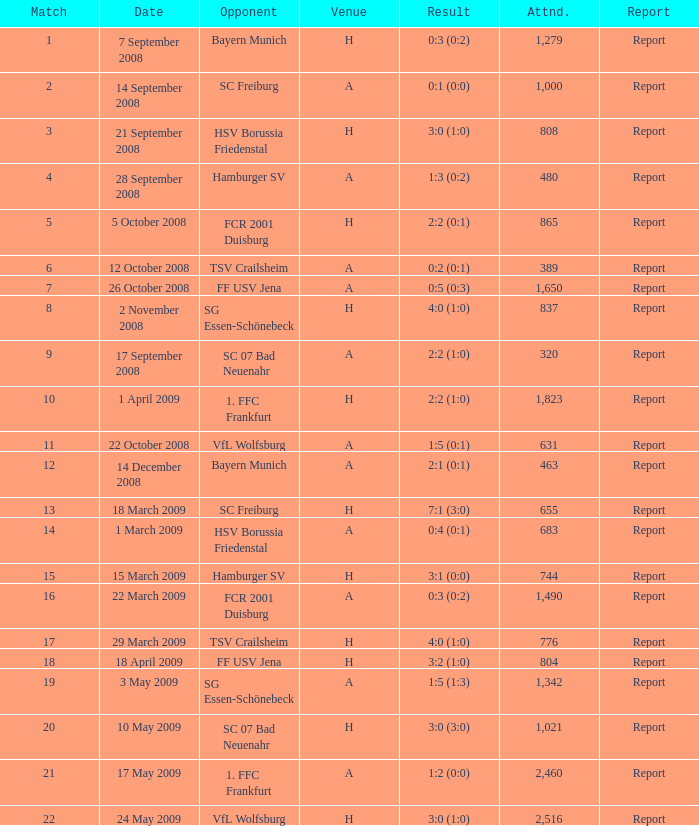During which encounter with more than 1,490 attendees did fcr 2001 duisburg secure a 0:3 (0:2) score? None. 